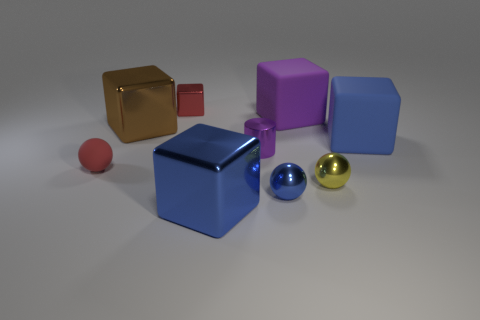There is a blue object that is the same shape as the yellow metallic object; what size is it?
Your response must be concise. Small. There is a rubber thing behind the large blue cube behind the matte sphere; how many red things are in front of it?
Make the answer very short. 1. Are there the same number of big cubes that are behind the small rubber thing and purple rubber blocks?
Offer a very short reply. No. What number of balls are either tiny brown rubber things or big purple matte objects?
Your response must be concise. 0. Do the small matte thing and the tiny cube have the same color?
Offer a very short reply. Yes. Are there the same number of tiny metal cylinders in front of the tiny red matte thing and yellow shiny objects that are behind the small red metal object?
Keep it short and to the point. Yes. The tiny metal cylinder has what color?
Provide a short and direct response. Purple. What number of objects are blue shiny objects in front of the small blue shiny ball or tiny red objects?
Your answer should be very brief. 3. There is a rubber object that is left of the tiny red block; is its size the same as the purple thing that is behind the brown metallic block?
Provide a short and direct response. No. How many things are either blue metallic things that are in front of the large brown object or things to the right of the yellow ball?
Offer a terse response. 3. 